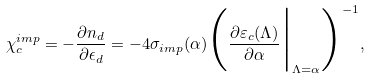<formula> <loc_0><loc_0><loc_500><loc_500>\chi _ { c } ^ { i m p } = - \frac { \partial n _ { d } } { \partial \epsilon _ { d } } = - 4 \sigma _ { i m p } ( \alpha ) \Big ( \frac { \partial \varepsilon _ { c } ( \Lambda ) } { \partial \alpha } \Big | _ { \Lambda = \alpha } \Big . \Big ) ^ { - 1 } ,</formula> 